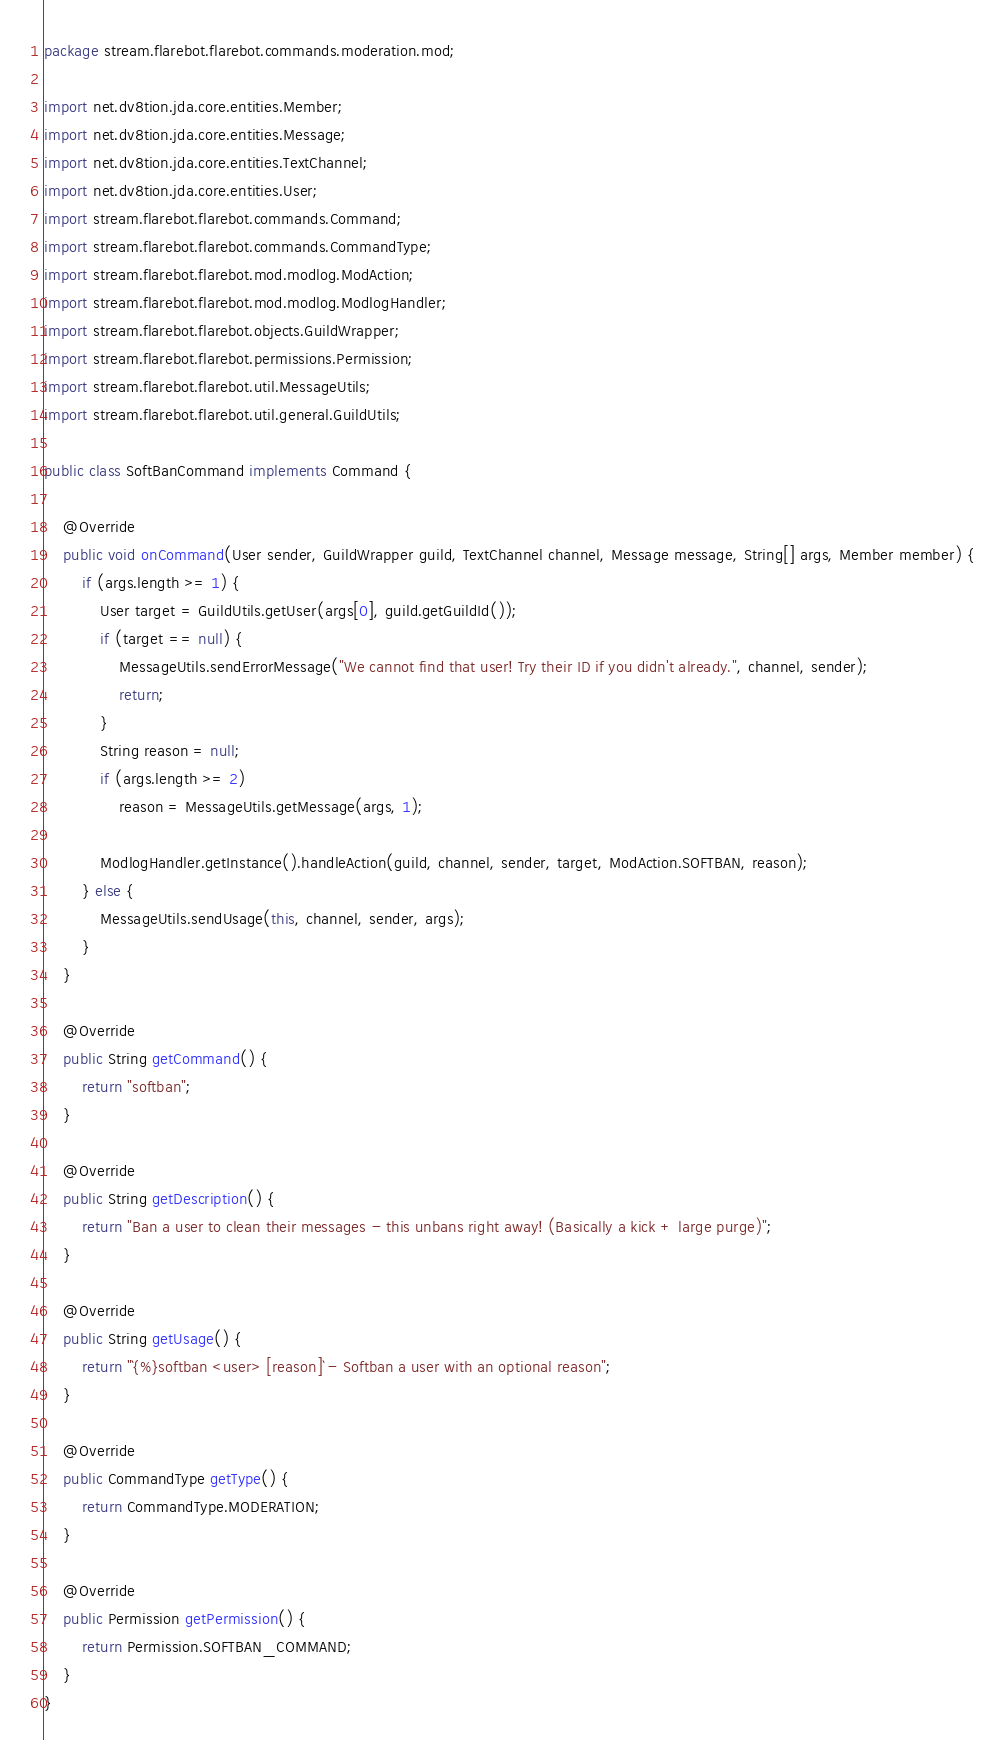Convert code to text. <code><loc_0><loc_0><loc_500><loc_500><_Java_>package stream.flarebot.flarebot.commands.moderation.mod;

import net.dv8tion.jda.core.entities.Member;
import net.dv8tion.jda.core.entities.Message;
import net.dv8tion.jda.core.entities.TextChannel;
import net.dv8tion.jda.core.entities.User;
import stream.flarebot.flarebot.commands.Command;
import stream.flarebot.flarebot.commands.CommandType;
import stream.flarebot.flarebot.mod.modlog.ModAction;
import stream.flarebot.flarebot.mod.modlog.ModlogHandler;
import stream.flarebot.flarebot.objects.GuildWrapper;
import stream.flarebot.flarebot.permissions.Permission;
import stream.flarebot.flarebot.util.MessageUtils;
import stream.flarebot.flarebot.util.general.GuildUtils;

public class SoftBanCommand implements Command {

    @Override
    public void onCommand(User sender, GuildWrapper guild, TextChannel channel, Message message, String[] args, Member member) {
        if (args.length >= 1) {
            User target = GuildUtils.getUser(args[0], guild.getGuildId());
            if (target == null) {
                MessageUtils.sendErrorMessage("We cannot find that user! Try their ID if you didn't already.", channel, sender);
                return;
            }
            String reason = null;
            if (args.length >= 2)
                reason = MessageUtils.getMessage(args, 1);

            ModlogHandler.getInstance().handleAction(guild, channel, sender, target, ModAction.SOFTBAN, reason);
        } else {
            MessageUtils.sendUsage(this, channel, sender, args);
        }
    }

    @Override
    public String getCommand() {
        return "softban";
    }

    @Override
    public String getDescription() {
        return "Ban a user to clean their messages - this unbans right away! (Basically a kick + large purge)";
    }

    @Override
    public String getUsage() {
        return "`{%}softban <user> [reason]` - Softban a user with an optional reason";
    }

    @Override
    public CommandType getType() {
        return CommandType.MODERATION;
    }

    @Override
    public Permission getPermission() {
        return Permission.SOFTBAN_COMMAND;
    }
}
</code> 